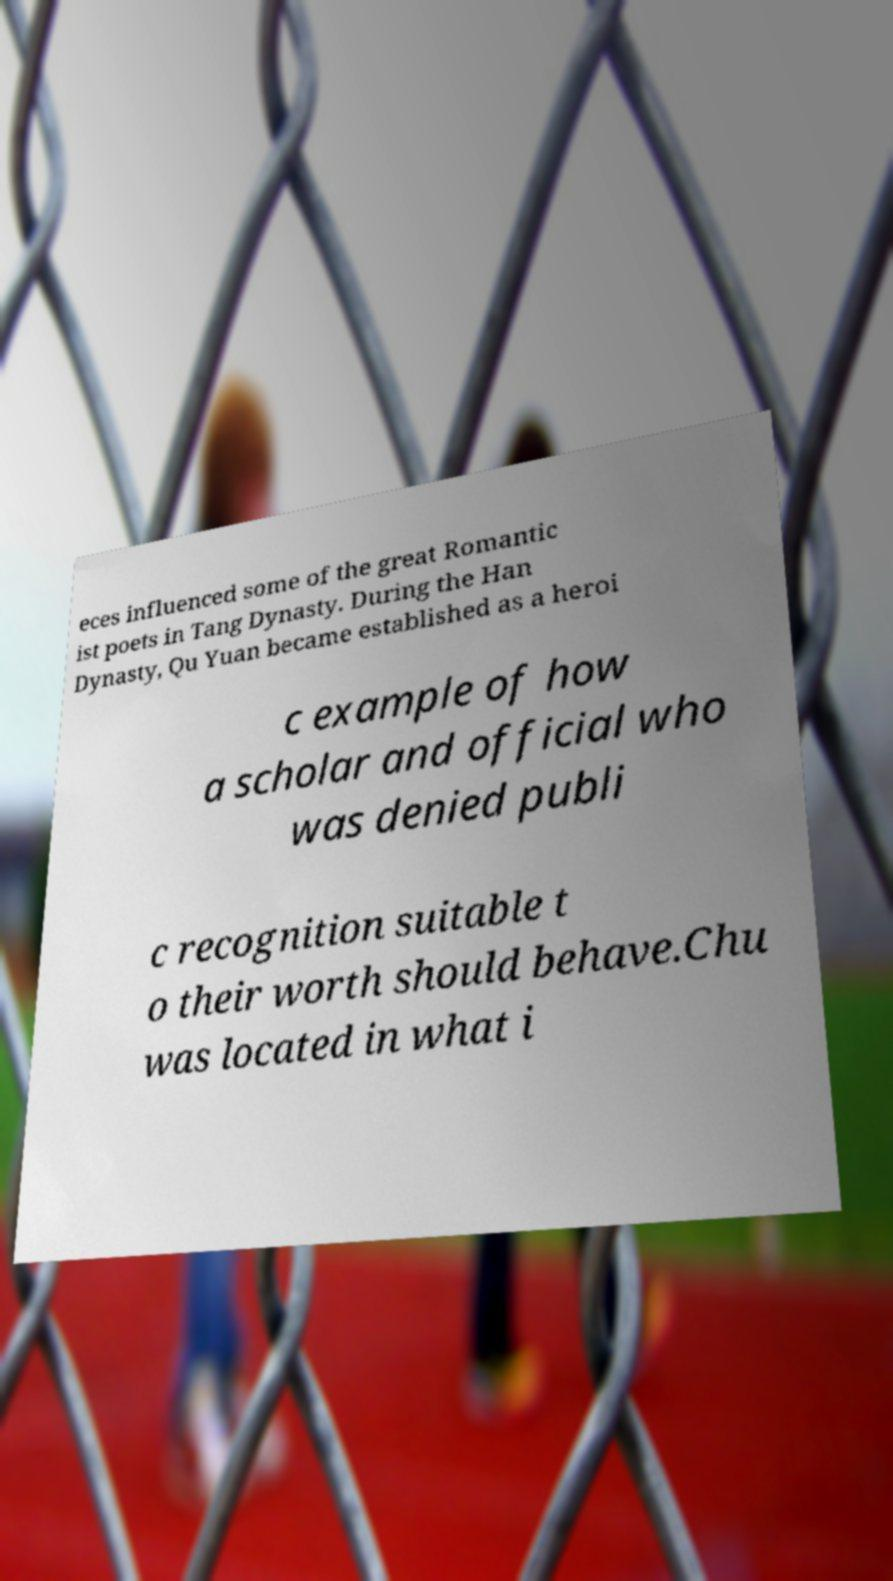Can you accurately transcribe the text from the provided image for me? eces influenced some of the great Romantic ist poets in Tang Dynasty. During the Han Dynasty, Qu Yuan became established as a heroi c example of how a scholar and official who was denied publi c recognition suitable t o their worth should behave.Chu was located in what i 